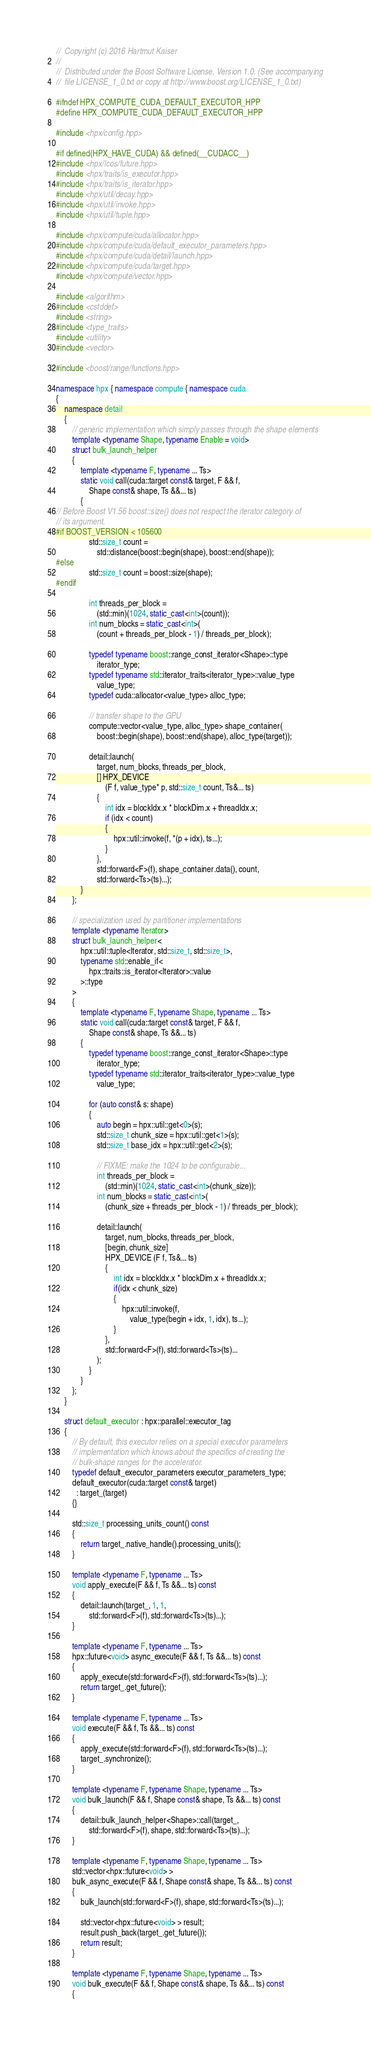Convert code to text. <code><loc_0><loc_0><loc_500><loc_500><_C++_>//  Copyright (c) 2016 Hartmut Kaiser
//
//  Distributed under the Boost Software License, Version 1.0. (See accompanying
//  file LICENSE_1_0.txt or copy at http://www.boost.org/LICENSE_1_0.txt)

#ifndef HPX_COMPUTE_CUDA_DEFAULT_EXECUTOR_HPP
#define HPX_COMPUTE_CUDA_DEFAULT_EXECUTOR_HPP

#include <hpx/config.hpp>

#if defined(HPX_HAVE_CUDA) && defined(__CUDACC__)
#include <hpx/lcos/future.hpp>
#include <hpx/traits/is_executor.hpp>
#include <hpx/traits/is_iterator.hpp>
#include <hpx/util/decay.hpp>
#include <hpx/util/invoke.hpp>
#include <hpx/util/tuple.hpp>

#include <hpx/compute/cuda/allocator.hpp>
#include <hpx/compute/cuda/default_executor_parameters.hpp>
#include <hpx/compute/cuda/detail/launch.hpp>
#include <hpx/compute/cuda/target.hpp>
#include <hpx/compute/vector.hpp>

#include <algorithm>
#include <cstddef>
#include <string>
#include <type_traits>
#include <utility>
#include <vector>

#include <boost/range/functions.hpp>

namespace hpx { namespace compute { namespace cuda
{
    namespace detail
    {
        // generic implementation which simply passes through the shape elements
        template <typename Shape, typename Enable = void>
        struct bulk_launch_helper
        {
            template <typename F, typename ... Ts>
            static void call(cuda::target const& target, F && f,
                Shape const& shape, Ts &&... ts)
            {
// Before Boost V1.56 boost::size() does not respect the iterator category of
// its argument.
#if BOOST_VERSION < 105600
                std::size_t count =
                    std::distance(boost::begin(shape), boost::end(shape));
#else
                std::size_t count = boost::size(shape);
#endif

                int threads_per_block =
                    (std::min)(1024, static_cast<int>(count));
                int num_blocks = static_cast<int>(
                    (count + threads_per_block - 1) / threads_per_block);

                typedef typename boost::range_const_iterator<Shape>::type
                    iterator_type;
                typedef typename std::iterator_traits<iterator_type>::value_type
                    value_type;
                typedef cuda::allocator<value_type> alloc_type;

                // transfer shape to the GPU
                compute::vector<value_type, alloc_type> shape_container(
                    boost::begin(shape), boost::end(shape), alloc_type(target));

                detail::launch(
                    target, num_blocks, threads_per_block,
                    [] HPX_DEVICE
                        (F f, value_type* p, std::size_t count, Ts&... ts)
                    {
                        int idx = blockIdx.x * blockDim.x + threadIdx.x;
                        if (idx < count)
                        {
                            hpx::util::invoke(f, *(p + idx), ts...);
                        }
                    },
                    std::forward<F>(f), shape_container.data(), count,
                    std::forward<Ts>(ts)...);
            }
        };

        // specialization used by partitioner implementations
        template <typename Iterator>
        struct bulk_launch_helper<
            hpx::util::tuple<Iterator, std::size_t, std::size_t>,
            typename std::enable_if<
                hpx::traits::is_iterator<Iterator>::value
            >::type
        >
        {
            template <typename F, typename Shape, typename ... Ts>
            static void call(cuda::target const& target, F && f,
                Shape const& shape, Ts &&... ts)
            {
                typedef typename boost::range_const_iterator<Shape>::type
                    iterator_type;
                typedef typename std::iterator_traits<iterator_type>::value_type
                    value_type;

                for (auto const& s: shape)
                {
                    auto begin = hpx::util::get<0>(s);
                    std::size_t chunk_size = hpx::util::get<1>(s);
                    std::size_t base_idx = hpx::util::get<2>(s);

                    // FIXME: make the 1024 to be configurable...
                    int threads_per_block =
                        (std::min)(1024, static_cast<int>(chunk_size));
                    int num_blocks = static_cast<int>(
                        (chunk_size + threads_per_block - 1) / threads_per_block);

                    detail::launch(
                        target, num_blocks, threads_per_block,
                        [begin, chunk_size]
                        HPX_DEVICE (F f, Ts&... ts)
                        {
                            int idx = blockIdx.x * blockDim.x + threadIdx.x;
                            if(idx < chunk_size)
                            {
                                hpx::util::invoke(f,
                                    value_type(begin + idx, 1, idx), ts...);
                            }
                        },
                        std::forward<F>(f), std::forward<Ts>(ts)...
                    );
                }
            }
        };
    }

    struct default_executor : hpx::parallel::executor_tag
    {
        // By default, this executor relies on a special executor parameters
        // implementation which knows about the specifics of creating the
        // bulk-shape ranges for the accelerator.
        typedef default_executor_parameters executor_parameters_type;
        default_executor(cuda::target const& target)
          : target_(target)
        {}

        std::size_t processing_units_count() const
        {
            return target_.native_handle().processing_units();
        }

        template <typename F, typename ... Ts>
        void apply_execute(F && f, Ts &&... ts) const
        {
            detail::launch(target_, 1, 1,
                std::forward<F>(f), std::forward<Ts>(ts)...);
        }

        template <typename F, typename ... Ts>
        hpx::future<void> async_execute(F && f, Ts &&... ts) const
        {
            apply_execute(std::forward<F>(f), std::forward<Ts>(ts)...);
            return target_.get_future();
        }

        template <typename F, typename ... Ts>
        void execute(F && f, Ts &&... ts) const
        {
            apply_execute(std::forward<F>(f), std::forward<Ts>(ts)...);
            target_.synchronize();
        }

        template <typename F, typename Shape, typename ... Ts>
        void bulk_launch(F && f, Shape const& shape, Ts &&... ts) const
        {
            detail::bulk_launch_helper<Shape>::call(target_,
                std::forward<F>(f), shape, std::forward<Ts>(ts)...);
        }

        template <typename F, typename Shape, typename ... Ts>
        std::vector<hpx::future<void> >
        bulk_async_execute(F && f, Shape const& shape, Ts &&... ts) const
        {
            bulk_launch(std::forward<F>(f), shape, std::forward<Ts>(ts)...);

            std::vector<hpx::future<void> > result;
            result.push_back(target_.get_future());
            return result;
        }

        template <typename F, typename Shape, typename ... Ts>
        void bulk_execute(F && f, Shape const& shape, Ts &&... ts) const
        {</code> 